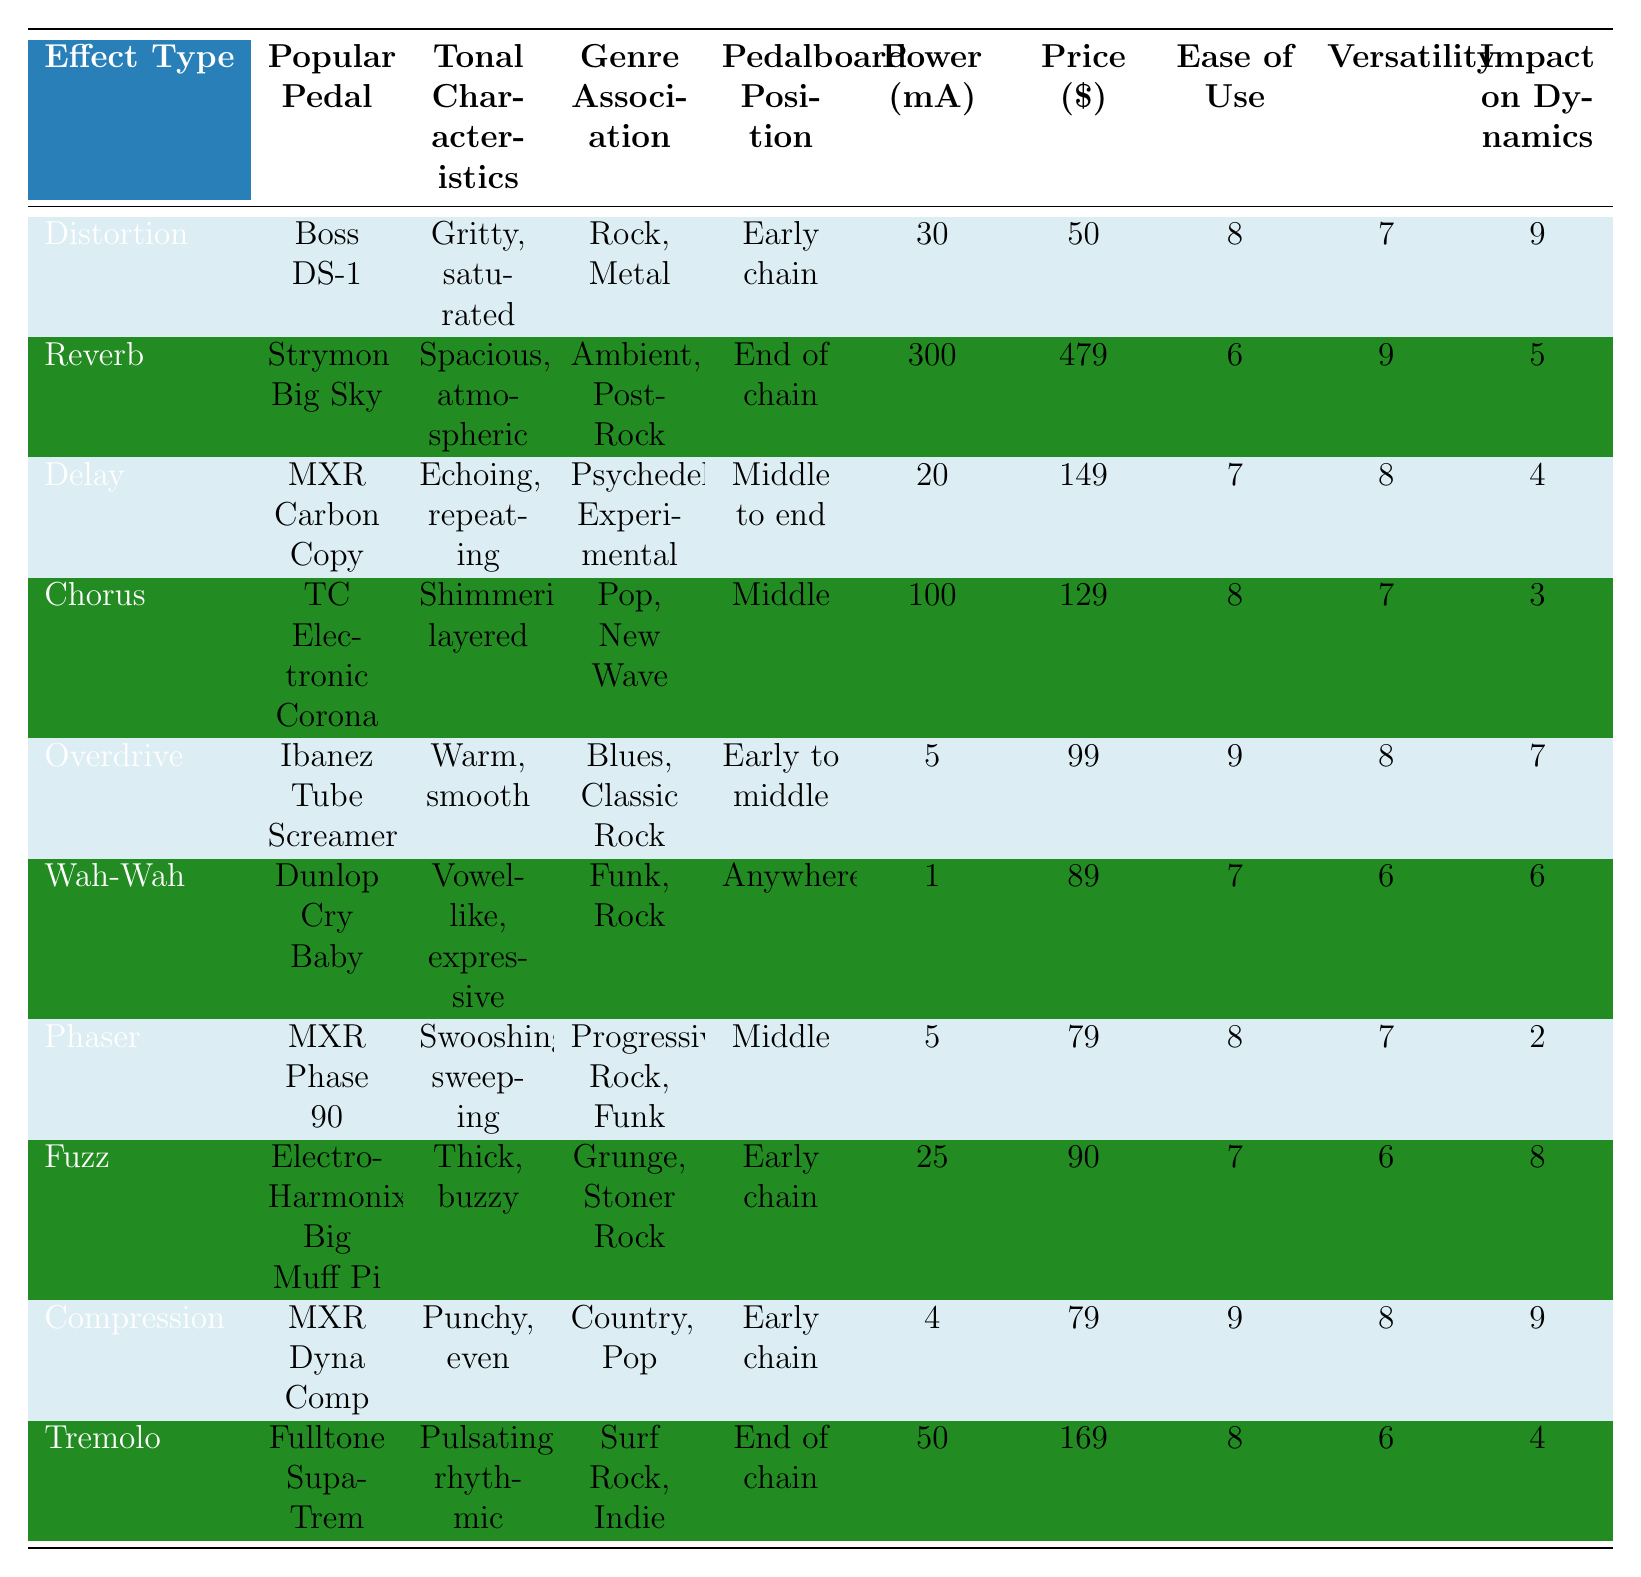What is the average price of the effects pedals listed? The prices listed are: 50, 479, 149, 129, 99, 89, 79, 90, 79, and 169. Summing these gives a total of 1,012. Since there are 10 pedals, the average price is 1,012 divided by 10, which equals 101.2.
Answer: 101.2 Which effect type is associated with the genre "Ambient, Post-Rock"? Looking at the Genre Association column, "Ambient, Post-Rock" corresponds to the Reverb effect type.
Answer: Reverb What is the power consumption of the Ibanez Tube Screamer? Referring to the Power Consumption column, the Ibanez Tube Screamer consumes 5 mA.
Answer: 5 mA Which effect has the highest ease of use rating? The Ease of Use ratings for the pedals are: 8, 6, 7, 8, 9, 7, 8, 7, 9, and 8. The highest rating is 9, which is shared by the Overdrive and Compression effects.
Answer: Overdrive and Compression Does the MXR Phase 90 have a higher or lower versatility rating than the MXR Carbon Copy? The versatility rating for MXR Phase 90 is 7, while for MXR Carbon Copy it is 8. Since 7 is less than 8, MXR Phase 90 has a lower versatility rating.
Answer: Lower Which effect type is placed at the end of the pedalboard? According to the Pedalboard Position column, the effects placed at the end of the chain are Reverb and Tremolo.
Answer: Reverb and Tremolo What is the total power consumption of all the pedals in the table? The power consumption values are: 30, 300, 20, 100, 5, 1, 5, 25, 4, and 50. Adding these together results in a total of 516 mA.
Answer: 516 mA Does every effect type provide a punchy impact on dynamics? Reviewing the Impact on Dynamics ratings, only Compression has a rating of 9, while others vary and some are lower. Thus, not every effect provides a punchy impact.
Answer: No What is the average ease of use score for the effects pedals? The Ease of Use ratings to sum are: 8, 6, 7, 8, 9, 7, 8, 7, 9, and 8. This totals 79. Dividing by 10 gives an average of 7.9.
Answer: 7.9 Which effect type has the lowest impact on dynamics and what is its score? Reviewing the Impact on Dynamics column shows that the Phaser has the lowest rating of 2.
Answer: Phaser, 2 